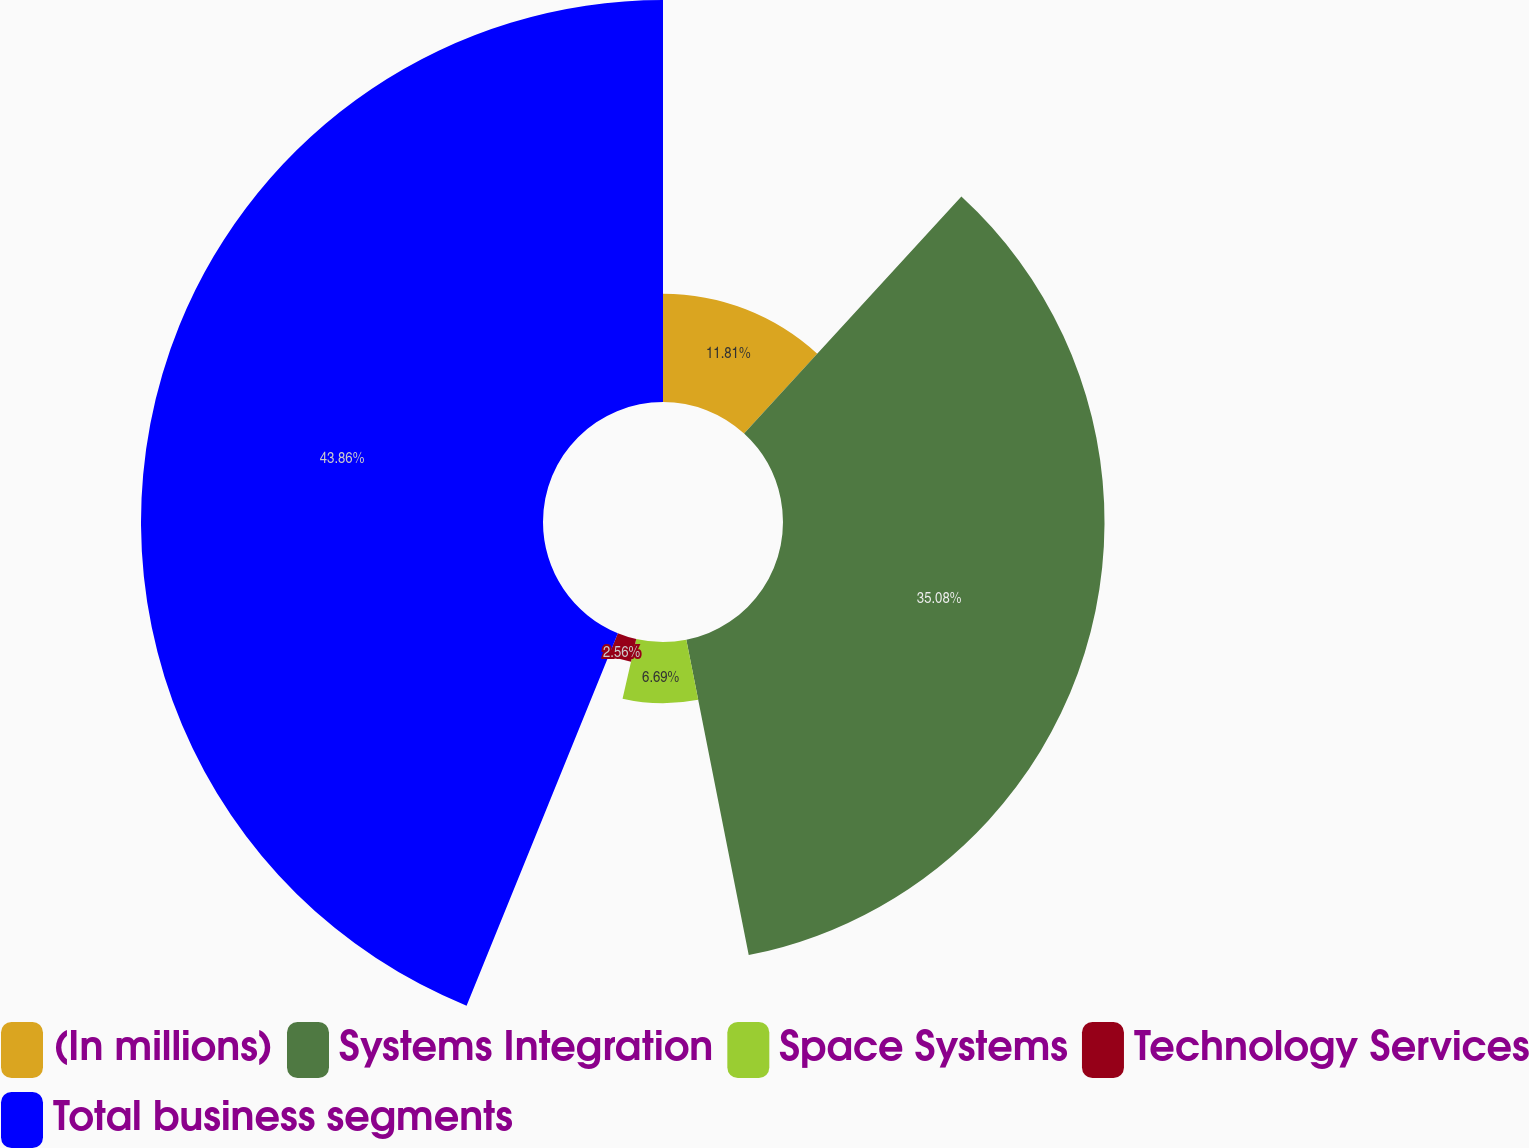Convert chart. <chart><loc_0><loc_0><loc_500><loc_500><pie_chart><fcel>(In millions)<fcel>Systems Integration<fcel>Space Systems<fcel>Technology Services<fcel>Total business segments<nl><fcel>11.81%<fcel>35.08%<fcel>6.69%<fcel>2.56%<fcel>43.86%<nl></chart> 